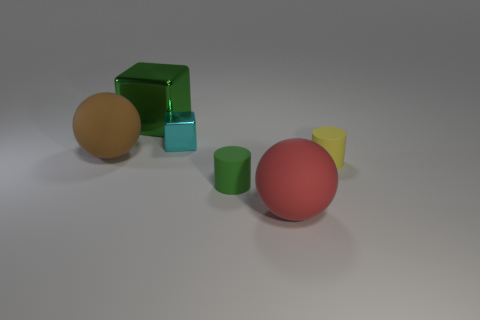Add 2 tiny cyan shiny objects. How many objects exist? 8 Add 5 red balls. How many red balls are left? 6 Add 2 small purple matte objects. How many small purple matte objects exist? 2 Subtract 1 brown balls. How many objects are left? 5 Subtract all small green rubber cylinders. Subtract all big green metallic blocks. How many objects are left? 4 